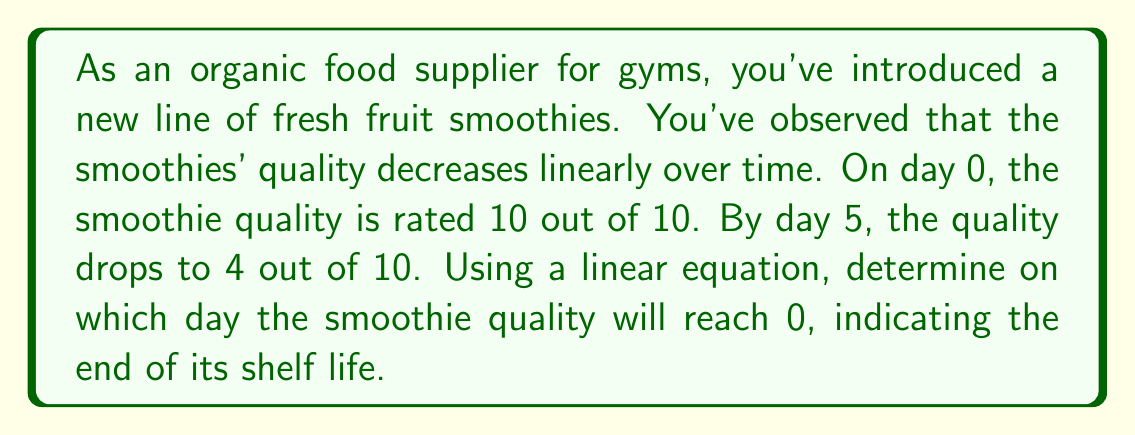Can you answer this question? Let's approach this step-by-step using a linear equation:

1) First, let's define our variables:
   $x$ = number of days
   $y$ = quality rating

2) We know two points on this line:
   $(0, 10)$ : On day 0, quality is 10
   $(5, 4)$ : On day 5, quality is 4

3) We can use the point-slope form of a line to create our equation:
   $y - y_1 = m(x - x_1)$

4) To find the slope $m$, we use:
   $m = \frac{y_2 - y_1}{x_2 - x_1} = \frac{4 - 10}{5 - 0} = \frac{-6}{5} = -1.2$

5) Now we can write our equation using the point $(0, 10)$:
   $y - 10 = -1.2(x - 0)$

6) Simplify:
   $y = -1.2x + 10$

7) To find when the quality reaches 0, we set $y = 0$:
   $0 = -1.2x + 10$

8) Solve for $x$:
   $1.2x = 10$
   $x = \frac{10}{1.2} = 8.33$

9) Since we can't have a fractional day, we round down to the nearest whole number.
Answer: The smoothie quality will reach 0 on day 8, indicating the end of its shelf life. 